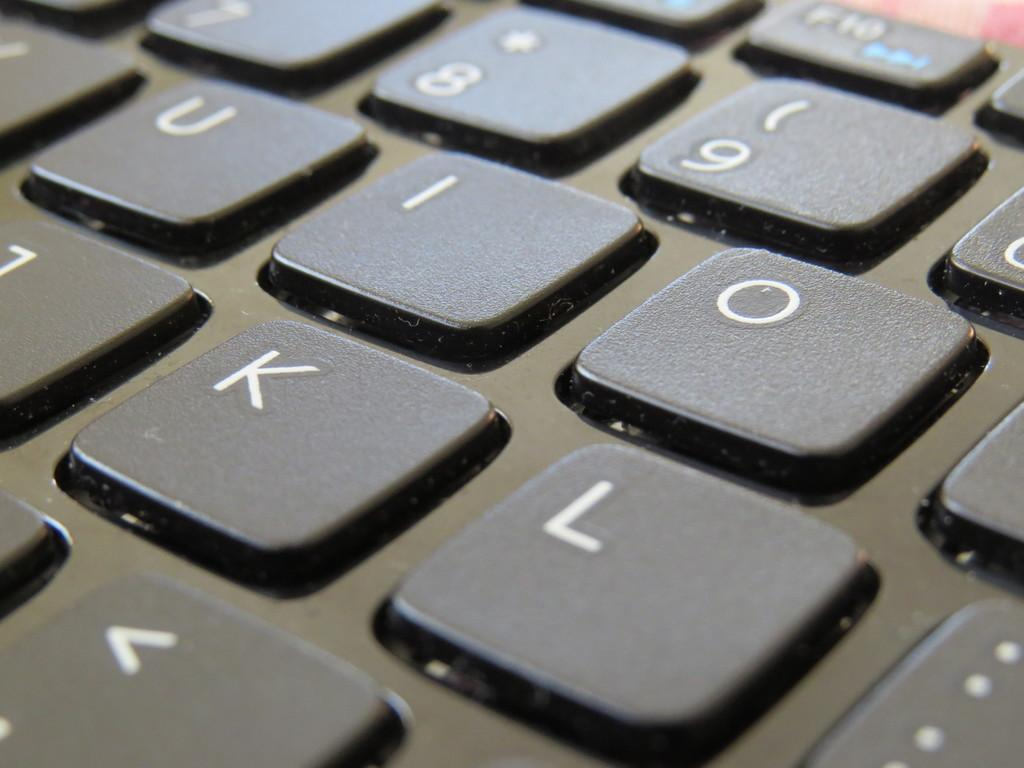<image>
Render a clear and concise summary of the photo. a close up of a keyboard with letters like K and L 